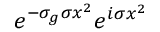Convert formula to latex. <formula><loc_0><loc_0><loc_500><loc_500>e ^ { - \sigma _ { g } \sigma x ^ { 2 } } e ^ { i \sigma x ^ { 2 } }</formula> 